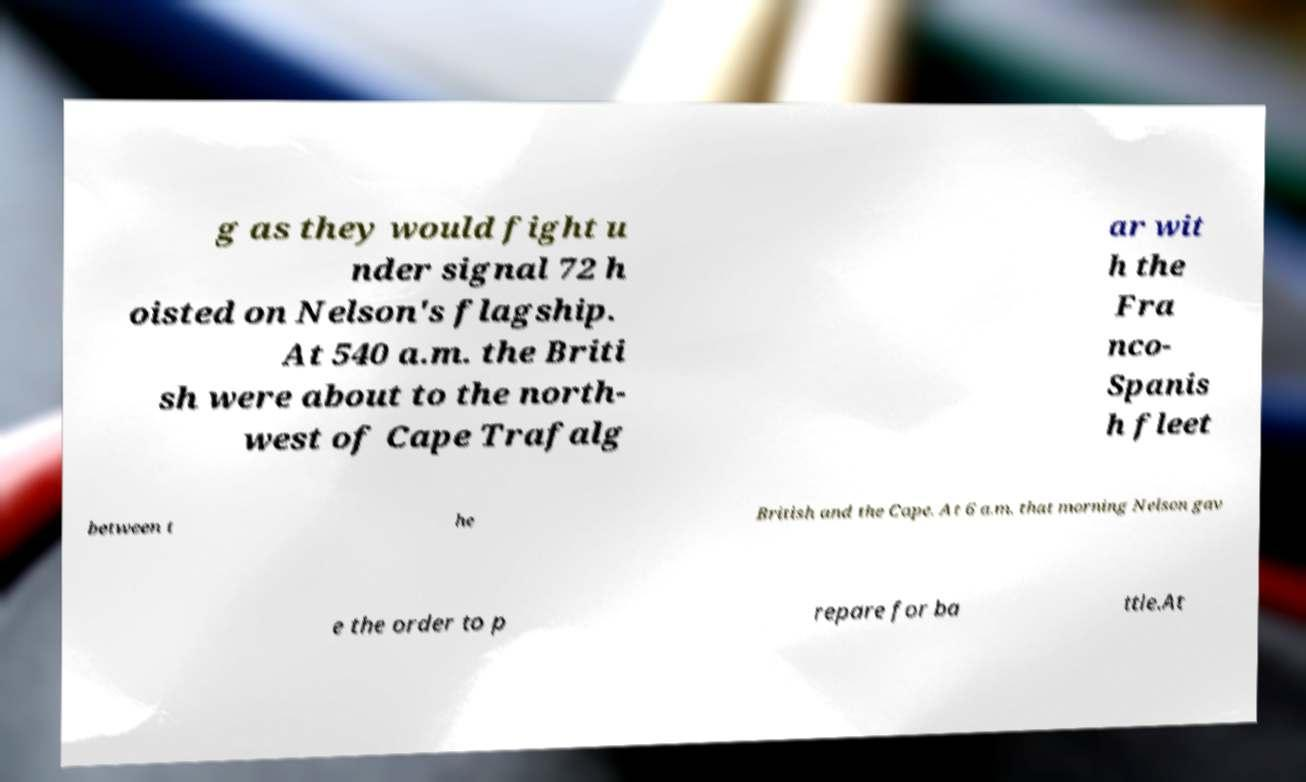I need the written content from this picture converted into text. Can you do that? g as they would fight u nder signal 72 h oisted on Nelson's flagship. At 540 a.m. the Briti sh were about to the north- west of Cape Trafalg ar wit h the Fra nco- Spanis h fleet between t he British and the Cape. At 6 a.m. that morning Nelson gav e the order to p repare for ba ttle.At 